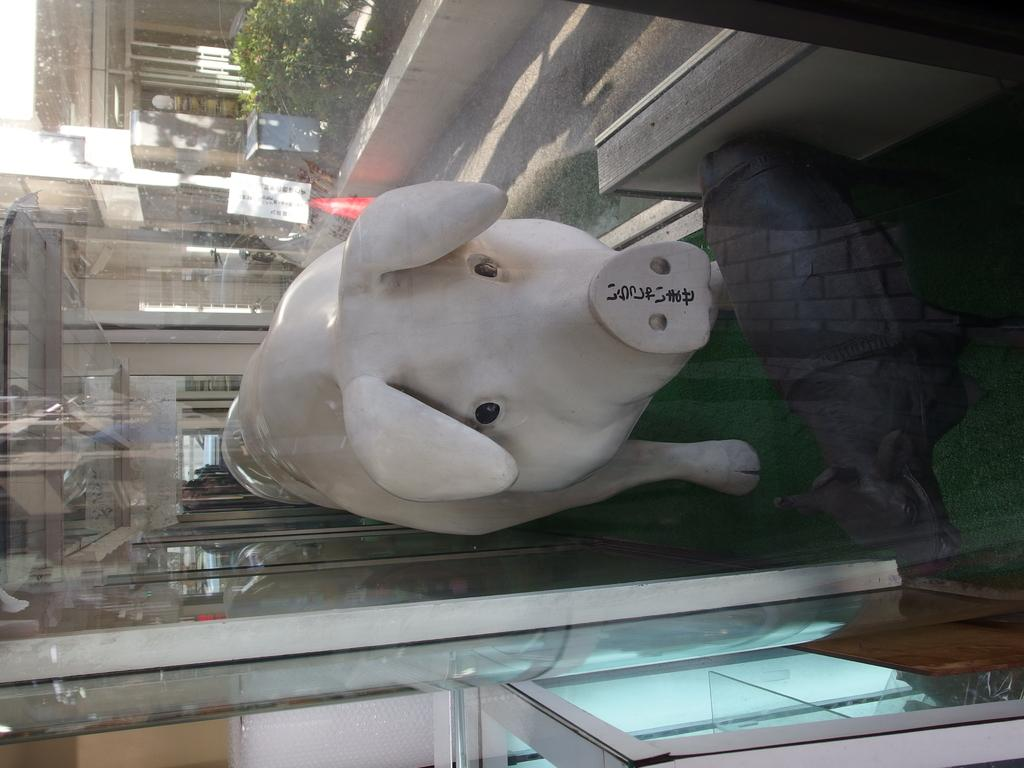What type of objects are present in the image? There are two animal statues in the image. Where are the animal statues located? The animal statues are in a display box. What type of plate is being used to serve popcorn in the image? There is no plate or popcorn present in the image; it features two animal statues in a display box. Can you tell me how many rocks are visible in the image? There are no rocks visible in the image; it features two animal statues in a display box. 